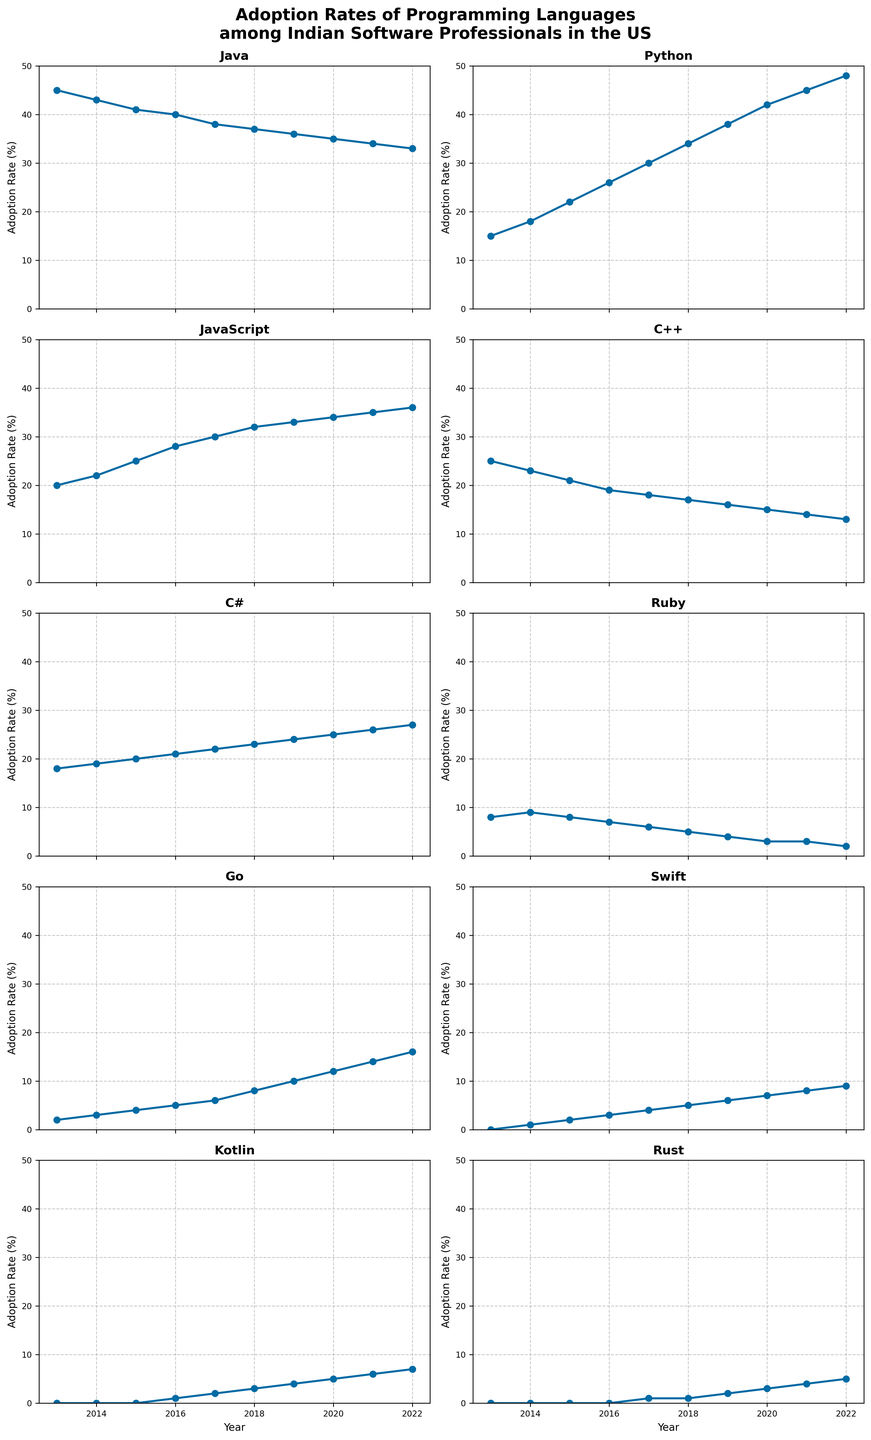Which programming language had the highest adoption rate in 2022? The highest point on the visual scale for 2022 corresponds to Python.
Answer: Python How did the adoption rate of Java change from 2013 to 2022? In 2013, Java's adoption rate was 45%. By 2022, it decreased to 33%.
Answer: Decreased by 12% Which programming language surpassed C++ in adoption rate first? Python surpassed C++ in 2015 where Python's rate was 22% and C++ was 21%.
Answer: Python Between which years did Rust see its highest growth in adoption rate? Rust saw its highest growth between 2021 (4%) and 2022 (5%).
Answer: 2021 to 2022 Comparing Swift and Kotlin, which had a higher adoption rate in 2018 and by how much? In 2018, Swift had 5% and Kotlin had 3%, so Swift was 2% higher.
Answer: Swift by 2% What was the trend in the adoption rate of C# from 2016 to 2022? The adoption rate of C# increased steadily from 2016 (21%) to 2022 (27%).
Answer: Increased In which year did Go become more popular than Ruby? Go surpassed Ruby in 2019 with Go at 10% and Ruby at 4%.
Answer: 2019 Which year saw the highest overall average adoption rate across all languages? Summing all rates per year and finding the average, 2019 had the highest average with rates summing up to 159.
Answer: 2019 Did JavaScript's adoption rate increase or decrease from 2013 to 2022, and by how much? JavaScript's rate increased from 20% in 2013 to 36% in 2022, so it increased by 16%.
Answer: Increased by 16% 